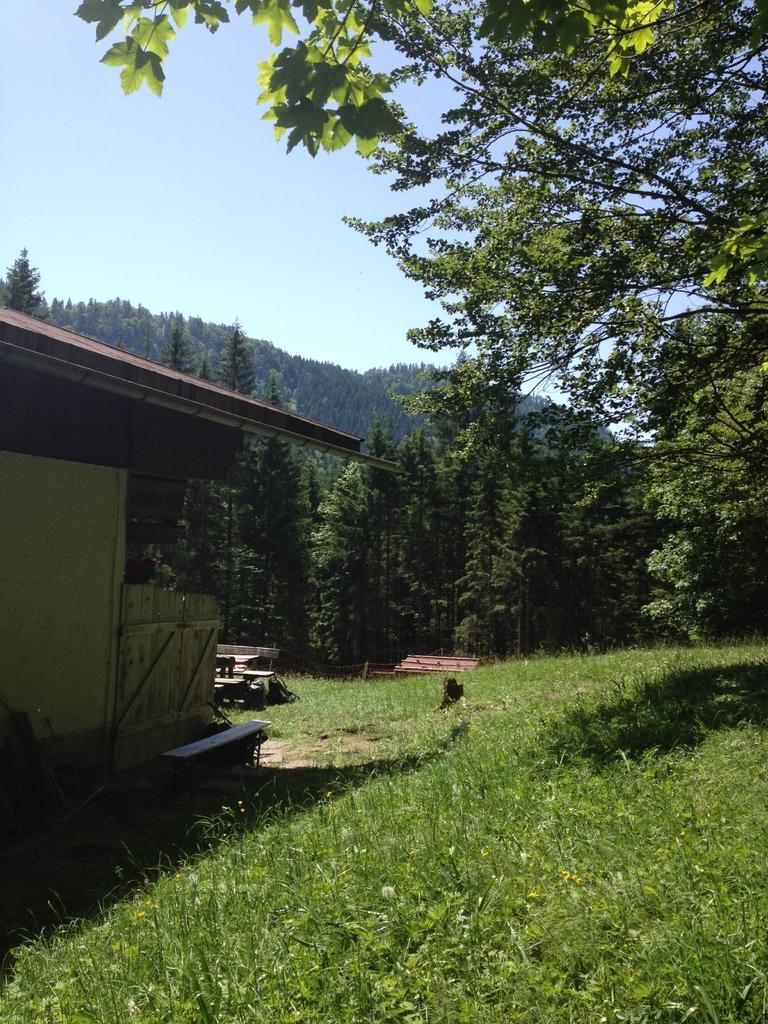Please provide a concise description of this image. In this image we can see a house with roof. We can also see some grass, bench and some trees. On the backside we can see the sky which looks cloudy. 